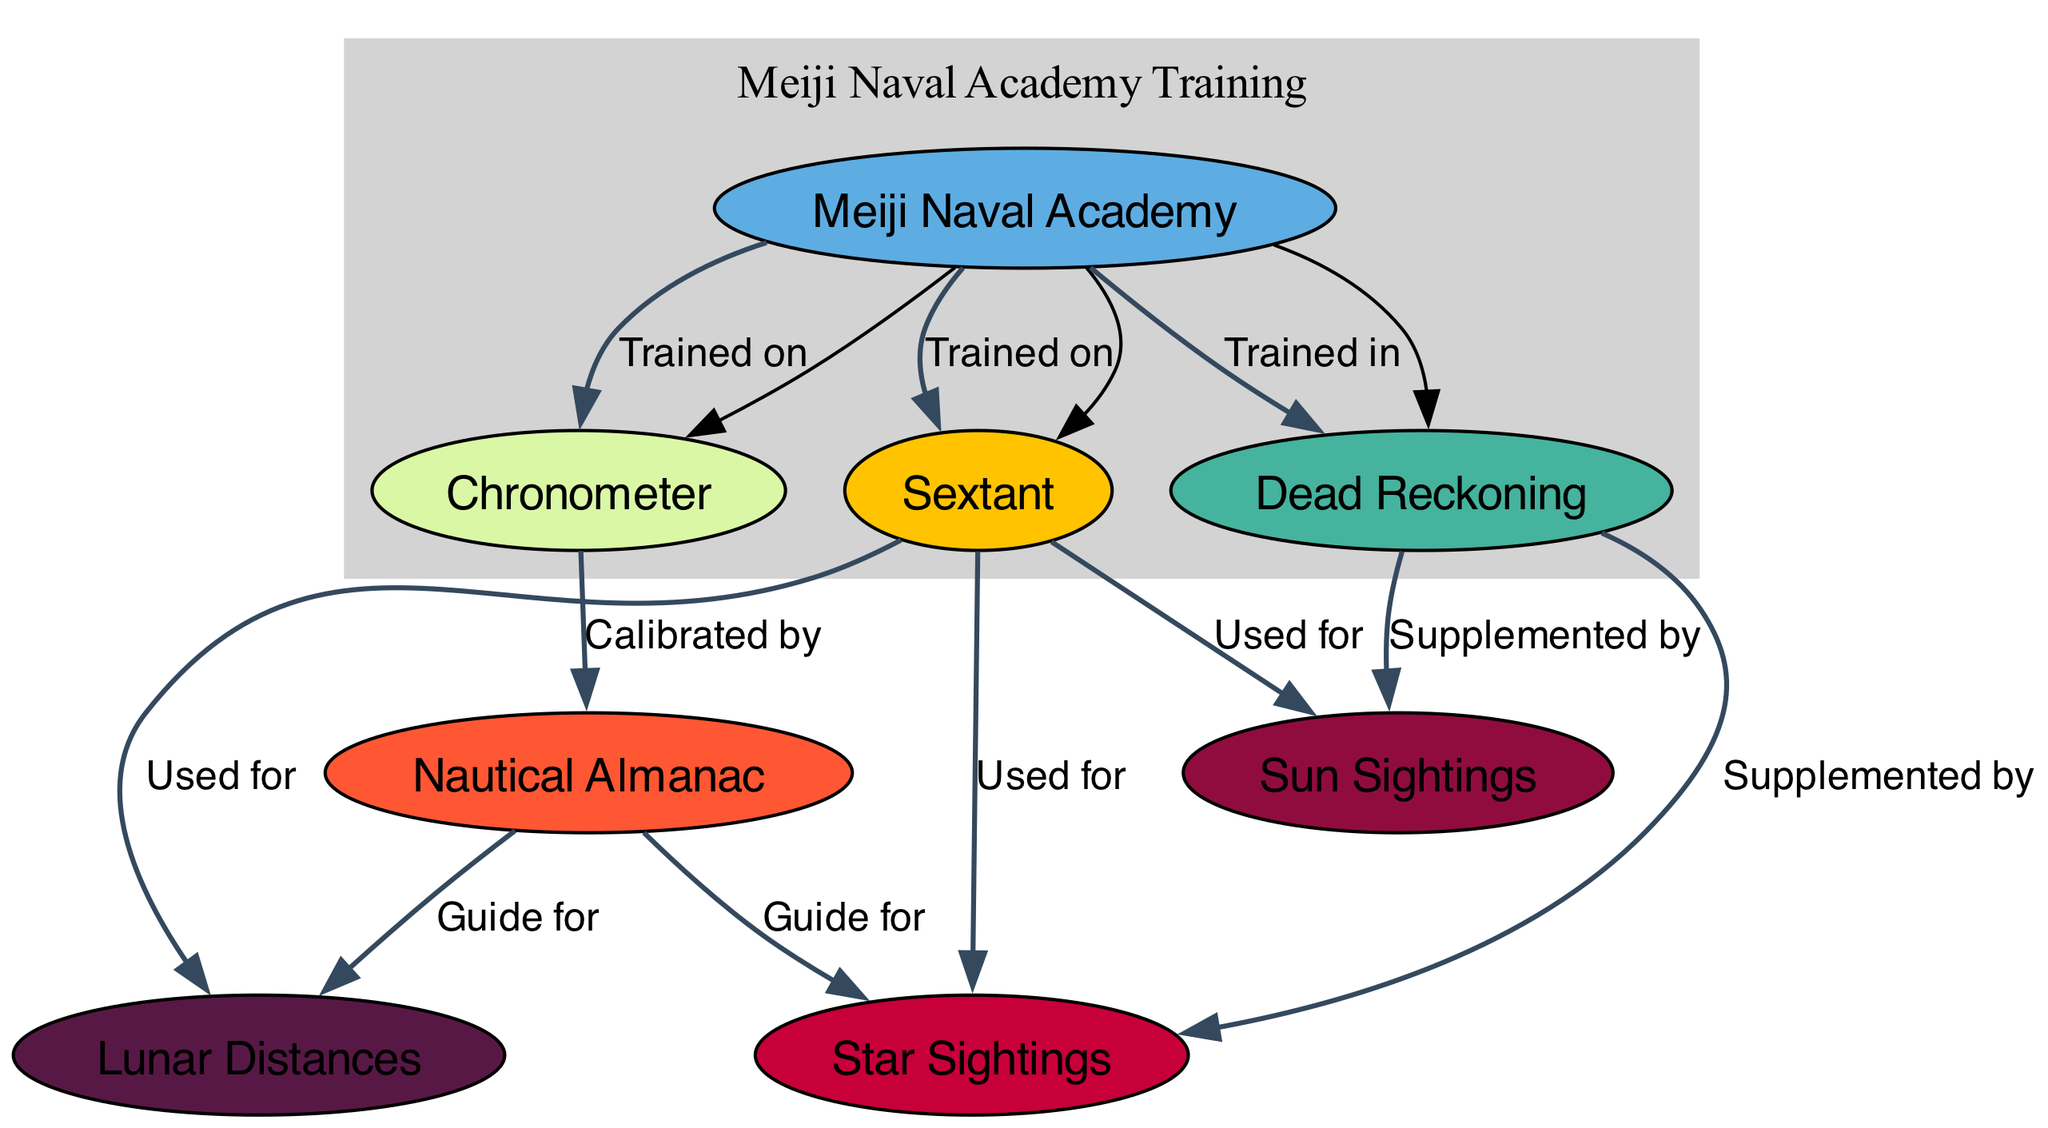What is the total number of nodes in the diagram? The diagram comprises a list of different elements associated with celestial navigation techniques. Counting them, there are a total of eight nodes represented.
Answer: 8 What does the sextant measure? According to the description in the node labeled 'Sextant', it measures the angle between two visible objects.
Answer: Angle between two visible objects Which two celestial sighting methods are directly supported by the sextant? The edges labeled 'Used for' show that the sextant is used for both star sightings and sun sightings. Therefore, these are the methods it directly supports.
Answer: Star sightings, Sun sightings How many edges are connected to the nautical almanac? The edges associated with the 'nautical almanac' show that it is connected to both star sightings and lunar distances as guides, making a total of two edges.
Answer: 2 What method is supplemented by both star and sun sightings? The connections from 'dead reckoning' to 'star sightings' and 'sun sightings' indicate that the dead reckoning method is supplemented by both of these sighting techniques.
Answer: Dead reckoning Which institution trained naval officers on the sextant and chronometer? The node labeled 'Meiji Naval Academy' features edges that indicate training on both the sextant and the chronometer, confirming that this institution provided such training.
Answer: Meiji Naval Academy Which celestial navigation technique is primarily based on previously determined locations? The method described in the node labeled 'Dead Reckoning' is specifically an estimation process based on previously determined locations, distinguishing it from sighting techniques.
Answer: Dead Reckoning What instrument is essential for calibrating the nautical almanac? The edge labeled 'Calibrated by' indicates that a chronometer is essential for the calibration of the nautical almanac, showing a dependency between these two elements.
Answer: Chronometer Which astronomical data publication is referenced for navigation guidance? The node that directly relates to navigation guidance is 'Nautical Almanac', which provides essential astronomical data necessary for various navigation techniques such as star sightings and lunar distances.
Answer: Nautical Almanac 